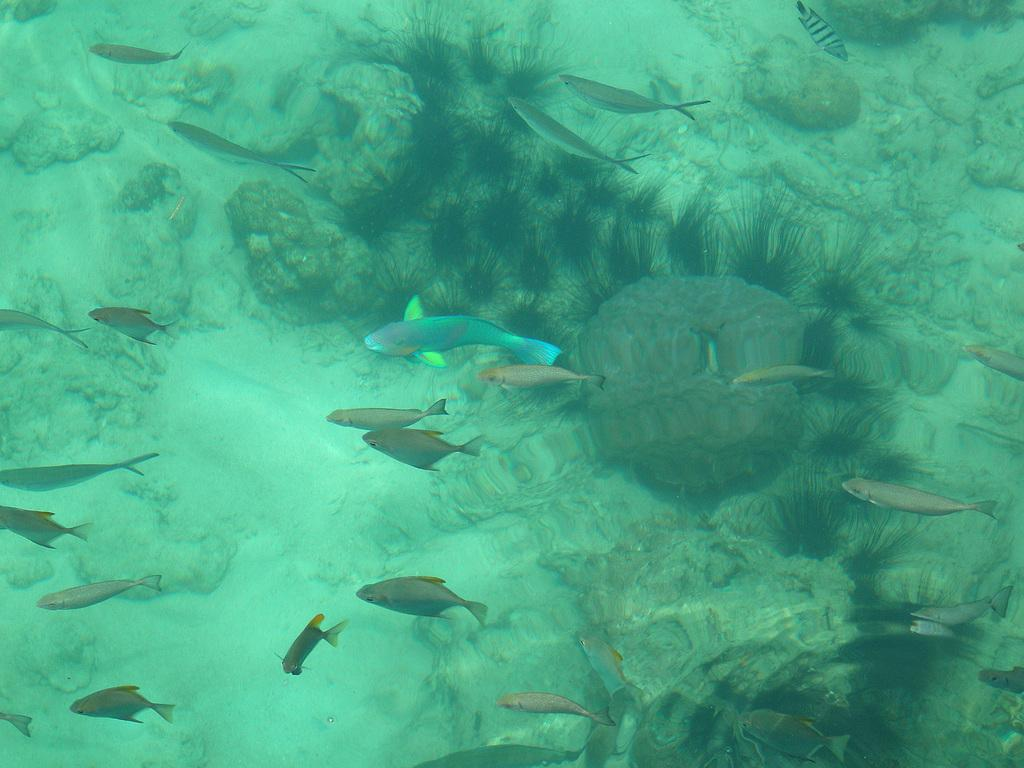What type of animals can be seen in the water in the image? There are fishes in the water. What other objects can be seen in the water? There are stones in the water. Are there any plants visible in the water? Yes, there is grass in the water. Can you see a coil in the water in the image? There is no coil present in the water in the image. How many hands are visible in the water in the image? There are no hands visible in the water in the image. 